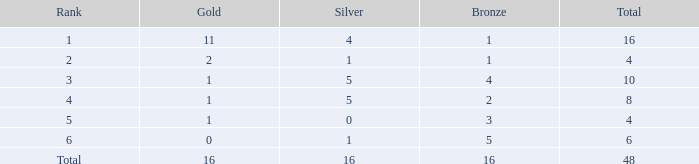How many gold pieces are in rank 1 and greater than 16? 0.0. 